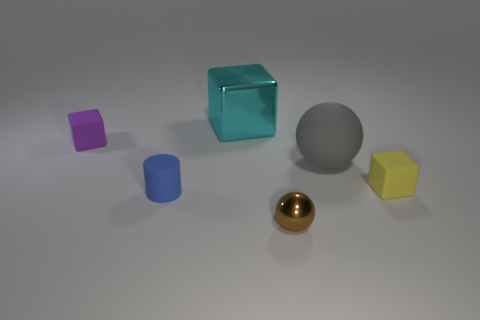Subtract all tiny blocks. How many blocks are left? 1 Subtract all gray blocks. Subtract all brown cylinders. How many blocks are left? 3 Add 2 tiny purple rubber objects. How many objects exist? 8 Add 4 small rubber things. How many small rubber things are left? 7 Add 5 tiny gray matte objects. How many tiny gray matte objects exist? 5 Subtract 0 cyan cylinders. How many objects are left? 6 Subtract all balls. How many objects are left? 4 Subtract all small spheres. Subtract all large cyan metal objects. How many objects are left? 4 